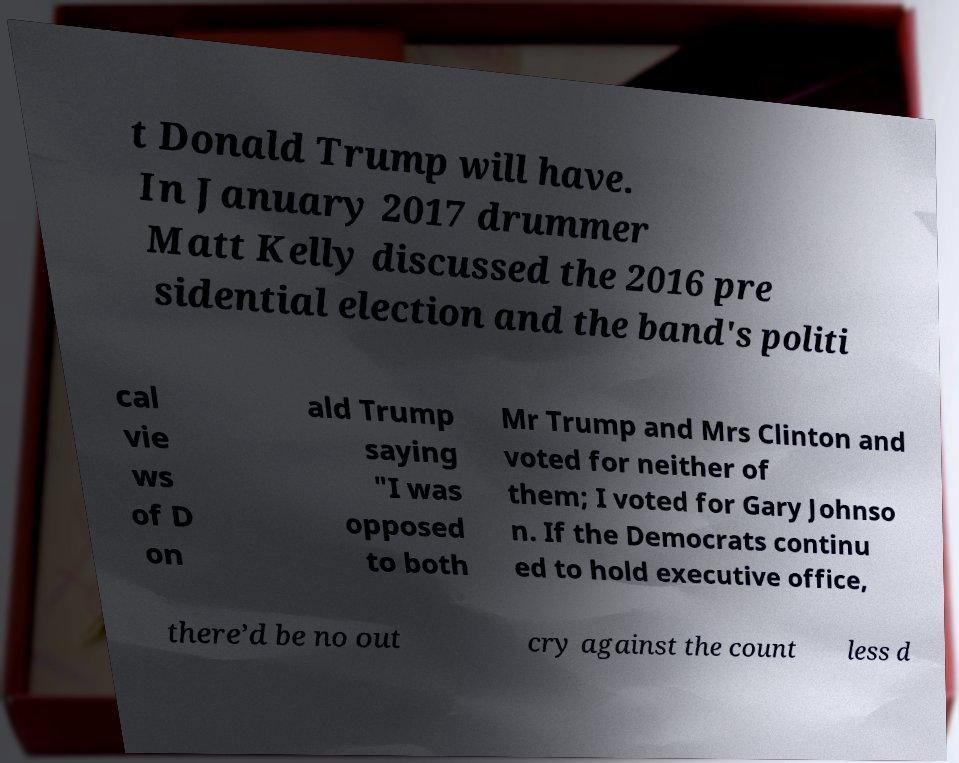Could you extract and type out the text from this image? t Donald Trump will have. In January 2017 drummer Matt Kelly discussed the 2016 pre sidential election and the band's politi cal vie ws of D on ald Trump saying "I was opposed to both Mr Trump and Mrs Clinton and voted for neither of them; I voted for Gary Johnso n. If the Democrats continu ed to hold executive office, there’d be no out cry against the count less d 